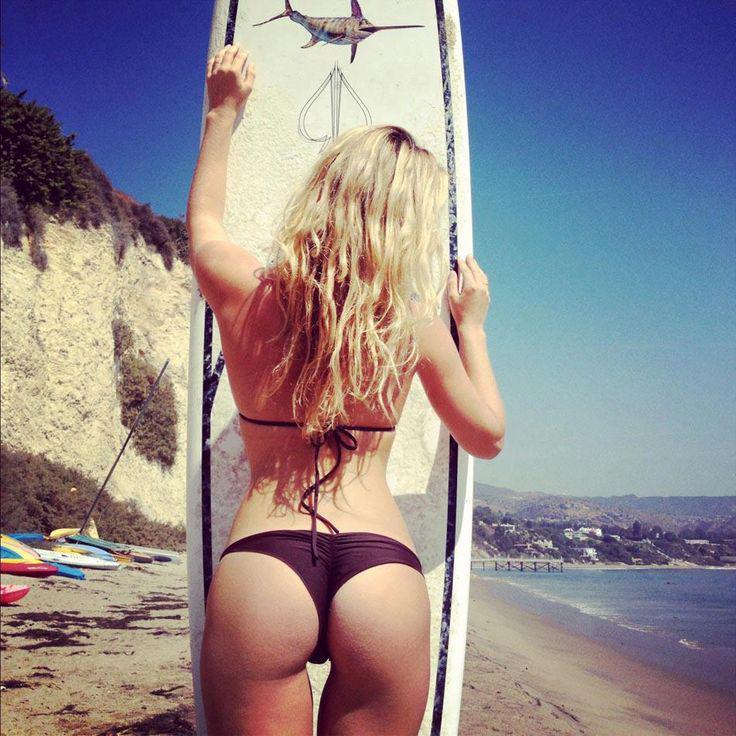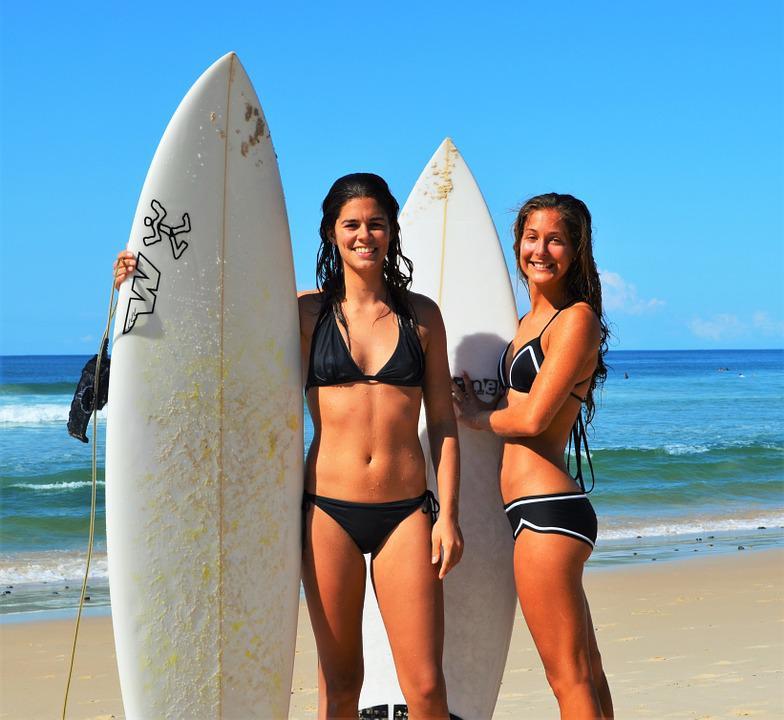The first image is the image on the left, the second image is the image on the right. Assess this claim about the two images: "An image shows just one bikini model facing the ocean and holding a surfboard on the right side.". Correct or not? Answer yes or no. No. The first image is the image on the left, the second image is the image on the right. Considering the images on both sides, is "There are four women with a surfboard." valid? Answer yes or no. No. 